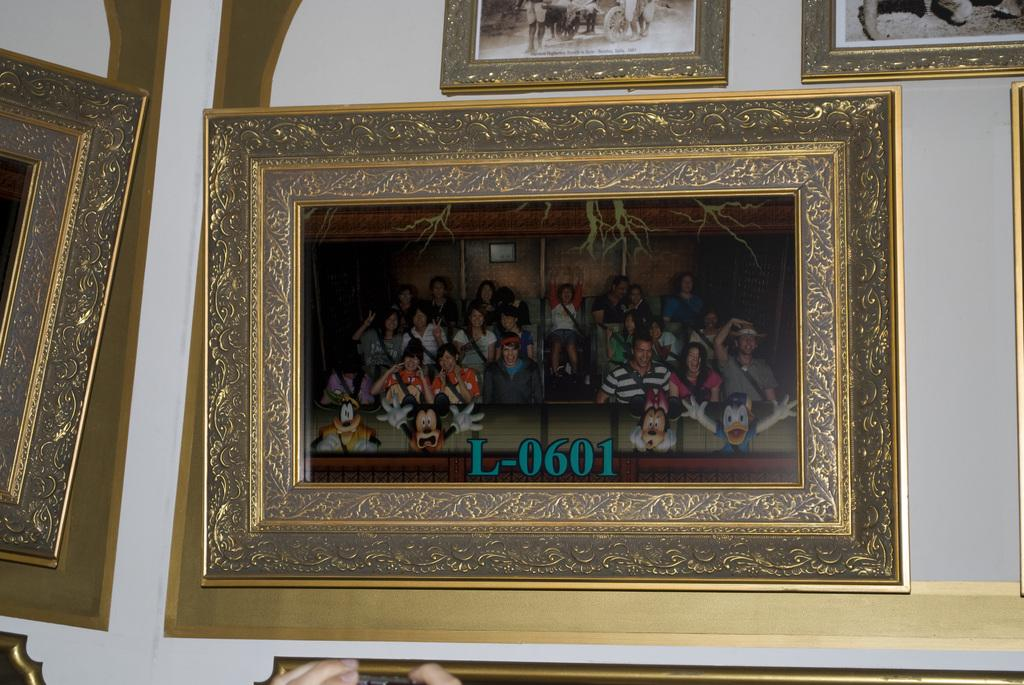<image>
Offer a succinct explanation of the picture presented. A photo with a gold frame is labelled L-0601. 